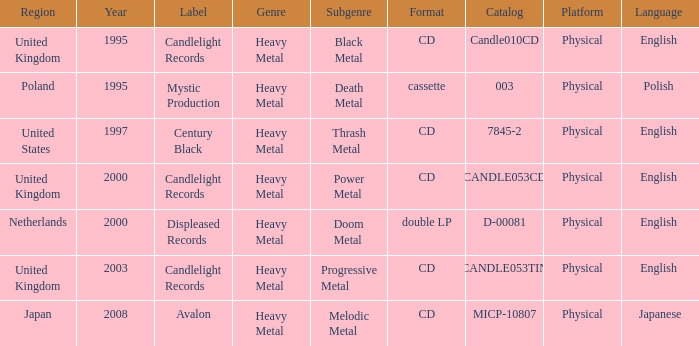What was the Candlelight Records Catalog of Candle053tin format? CD. 